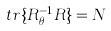<formula> <loc_0><loc_0><loc_500><loc_500>t r \{ R _ { \theta } ^ { - 1 } R \} = N \text { }</formula> 